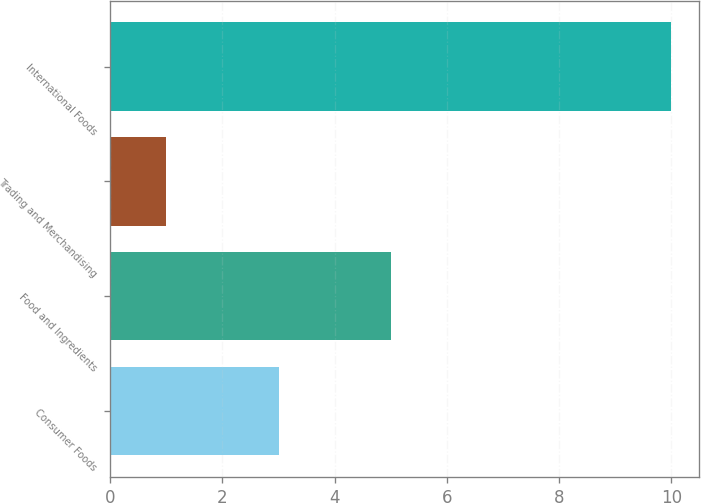<chart> <loc_0><loc_0><loc_500><loc_500><bar_chart><fcel>Consumer Foods<fcel>Food and Ingredients<fcel>Trading and Merchandising<fcel>International Foods<nl><fcel>3<fcel>5<fcel>1<fcel>10<nl></chart> 